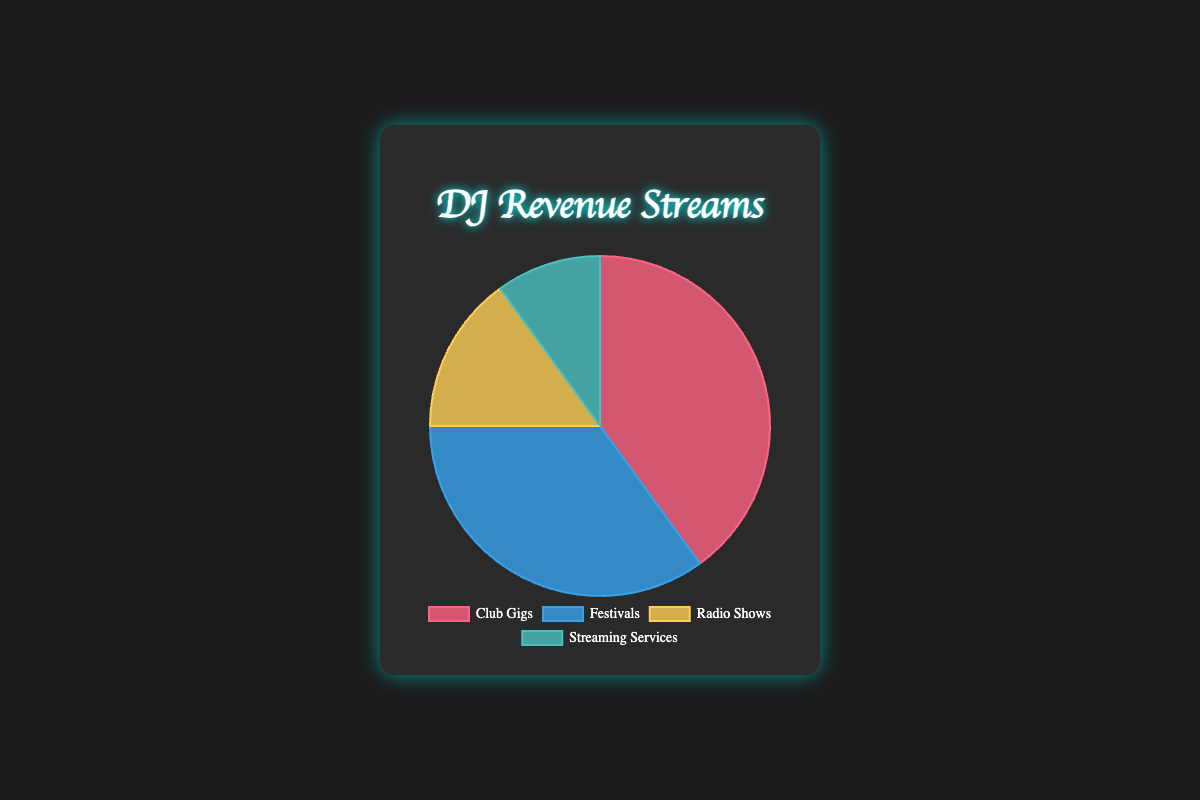What is the largest revenue stream for the DJ? The pie chart shows that the largest segment is Club Gigs with a percentage of 40%.
Answer: Club Gigs What percentage of revenue comes from Festivals and Radio Shows combined? The Festivals percentage is 35% and Radio Shows is 15%. Summing these two percentages, 35% + 15% = 50%.
Answer: 50% Which revenue stream contributes the least to the DJ's income? The pie chart indicates that Streaming Services have the smallest percentage at 10%.
Answer: Streaming Services How much greater is the percentage of revenue from Club Gigs compared to Streaming Services? Club Gigs contribute 40% while Streaming Services contribute 10%. The difference is 40% - 10% = 30%.
Answer: 30% If the DJ decides to increase revenue from Radio Shows by 5%, what will be the new percentage for Radio Shows? The current percentage is 15%. Increasing it by 5% results in 15% + 5% = 20%.
Answer: 20% Which two revenue streams together make up more than half of the total income? Club Gigs are 40% and Festivals are 35%. Together they make 40% + 35% = 75%, which is more than half.
Answer: Club Gigs and Festivals What is the difference in percentage between the two smallest revenue streams? Radio Shows have 15% and Streaming Services have 10%. The difference is 15% - 10% = 5%.
Answer: 5% What is the total percentage of revenue generated from non-gig sources (Radio Shows and Streaming Services)? Radio Shows account for 15% and Streaming Services for 10%. Adding these gives 15% + 10% = 25%.
Answer: 25% Which revenue stream's percentage is the closest to one-third of the total revenue? One-third of the total revenue is approximately 33.33%. The closest percentage is festivals with 35%.
Answer: Festivals Describe the segment color associated with Radio Shows in the pie chart. The pie chart segment for Radio Shows is colored yellowish.
Answer: Yellowish 